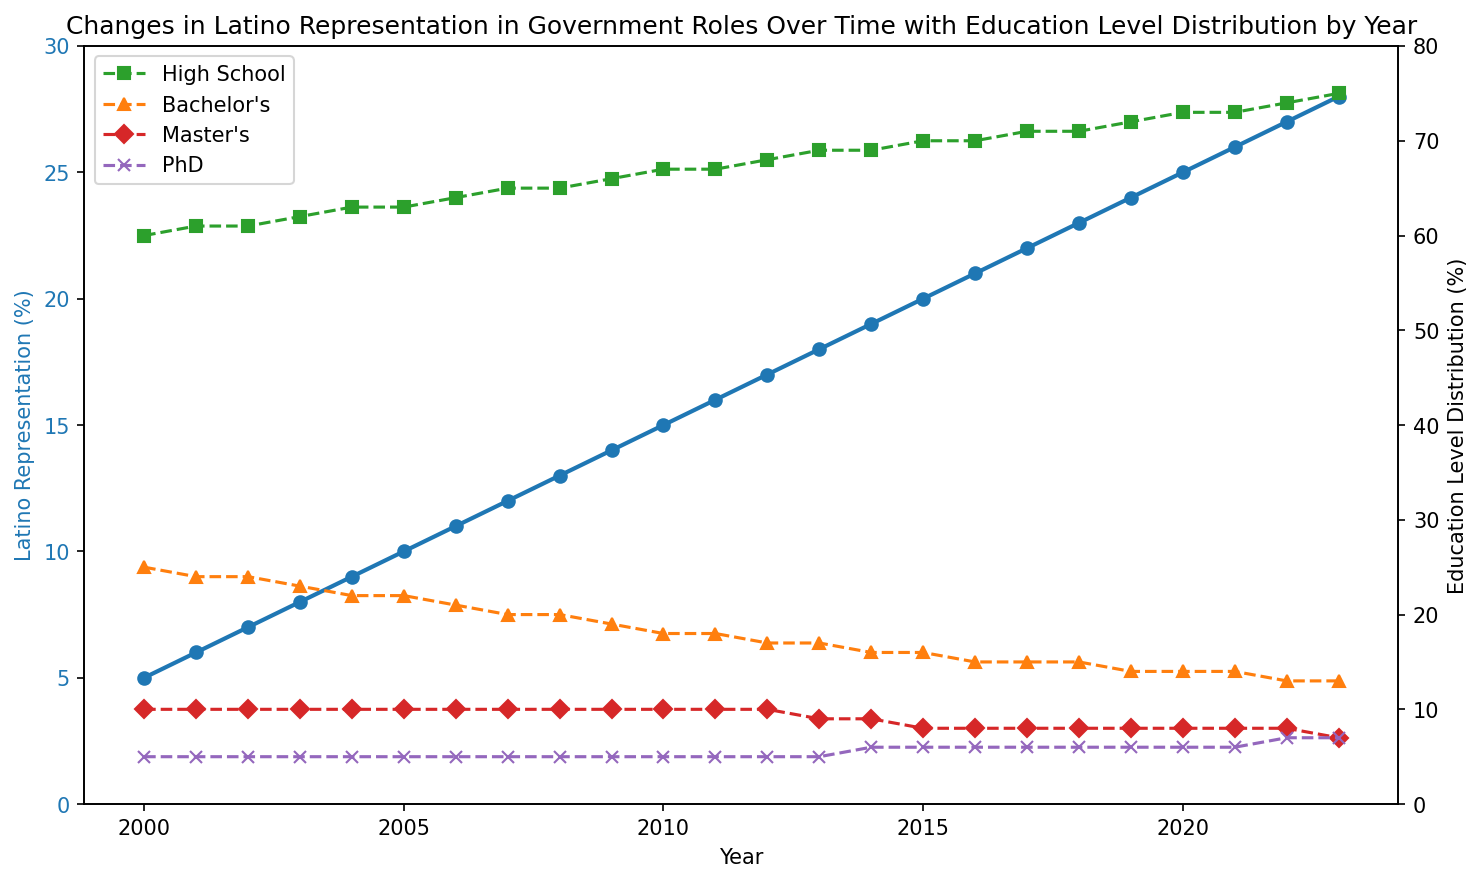How has Latino representation in government roles changed from 2000 to 2023? The Latino representation increased steadily from 5% in 2000 to 28% in 2023.
Answer: Increased from 5% to 28% Which education level category showed the most significant change in percentage from 2000 to 2023? The percentage of individuals with only a high school education increased from 60% in 2000 to 75% in 2023, showing the most significant change.
Answer: High school In which year did the Latino representation in government roles first reach 20%? By tracing the Latino representation line, 20% was first reached in 2015.
Answer: 2015 How did the percentage of people with a PhD change from 2012 to 2022? The PhD percentage remained constant at 5% from 2012 until 2014, increased to 6% in 2015, and rose to 7% in 2022.
Answer: Increased from 5% to 7% Compare the change in bachelor's degree percentages and master's degree percentages from 2000 to 2023. Which category decreased more? Bachelor's degrees decreased from 25% to 13%, a change of 12 percentage points. Master's degrees decreased from 10% to 7%, a change of 2 percentage points. Therefore, bachelor's degrees decreased more.
Answer: Bachelor's degrees What was the percentage change in high school education level from 2005 to 2015? The high school education level increased from 63% in 2005 to 70% in 2015. This is an increase of 7 percentage points.
Answer: Increased by 7% Which year saw an equal percentage of bachelor's and master's degrees? By inspecting the graph, the bachelor's degree and master's degree percentages were equal (10%) in 2000.
Answer: 2000 Is there a visible trend in the percentage of individuals with master's degrees from 2000 to 2023? The graph shows a slight decreasing trend in the percentage of individuals with master's degrees, from 10% in 2000 to 7% in 2023.
Answer: Decreasing trend What is the difference in Latino representation between the years 2010 and 2020? In 2010, Latino representation was 15%, and in 2020, it was 25%. The difference is 25% - 15% = 10%.
Answer: 10% Which educational category had the least change from 2000 to 2023? The PhD category had the least change, remaining relatively stable around 5-7%.
Answer: PhD 